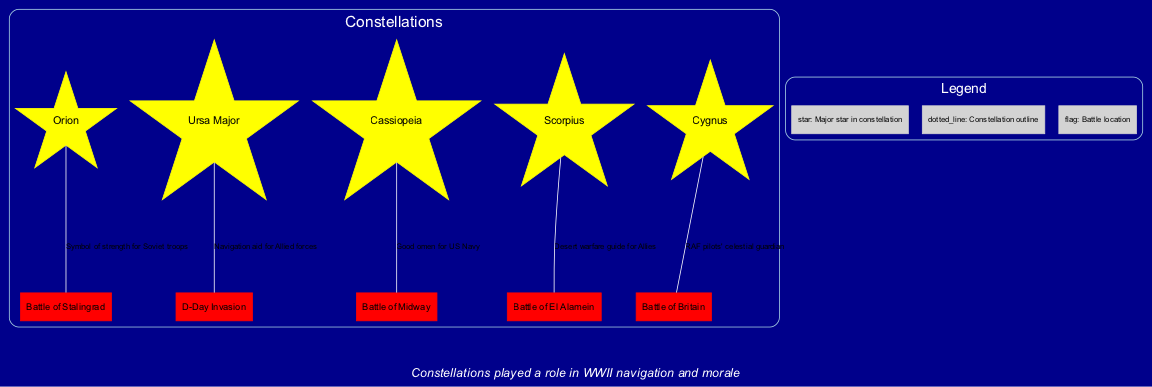What constellation is associated with the Battle of Stalingrad? The diagram indicates that Orion is linked with the Battle of Stalingrad, as it is labeled next to that particular battle.
Answer: Orion How many constellations are depicted in the diagram? By counting the number of distinct constellations listed, we find five constellations: Orion, Ursa Major, Cassiopeia, Scorpius, and Cygnus.
Answer: 5 What was the significance of Ursa Major in the context of the D-Day Invasion? The relationship drawn between Ursa Major and D-Day Invasion demonstrates that it served as a navigation aid for Allied forces, as indicated by the label connecting these nodes.
Answer: Navigation aid for Allied forces Which constellation acted as a celestial guardian for RAF pilots during the Battle of Britain? The diagram specifies that Cygnus is recognized as the celestial guardian for RAF pilots, per the annotation linked to the battle.
Answer: Cygnus For which battle is Cassiopeia considered a good omen? The connection between Cassiopeia and the Battle of Midway shows that it is regarded as a good omen for the US Navy in this context.
Answer: Battle of Midway What is the significance of Scorpius in the context of Desert warfare? The significance of Scorpius is elucidated in the diagram where it is mentioned as a guide for Allies in desert warfare for the Battle of El Alamein.
Answer: Desert warfare guide for Allies How does the note at the bottom contribute to understanding the diagram's context? The note indicates that constellations played roles not only in navigation but also in boosting morale during WWII, connecting the astronomical elements with the wartime themes.
Answer: Navigation and morale What do the dotted lines represent in the diagram? Dotted lines in the diagram symbolize the outline of constellations, which visually differentiate the shapes of the constellations from the battle locations.
Answer: Constellation outline Which constellation is linked to the Battle of Midway? Cassiopeia is directly linked to the Battle of Midway as per the available information in the diagram, illustrating its relevance to that particular battle.
Answer: Cassiopeia 